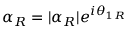Convert formula to latex. <formula><loc_0><loc_0><loc_500><loc_500>\alpha _ { R } = | \alpha _ { R } | e ^ { i \theta _ { 1 R } }</formula> 